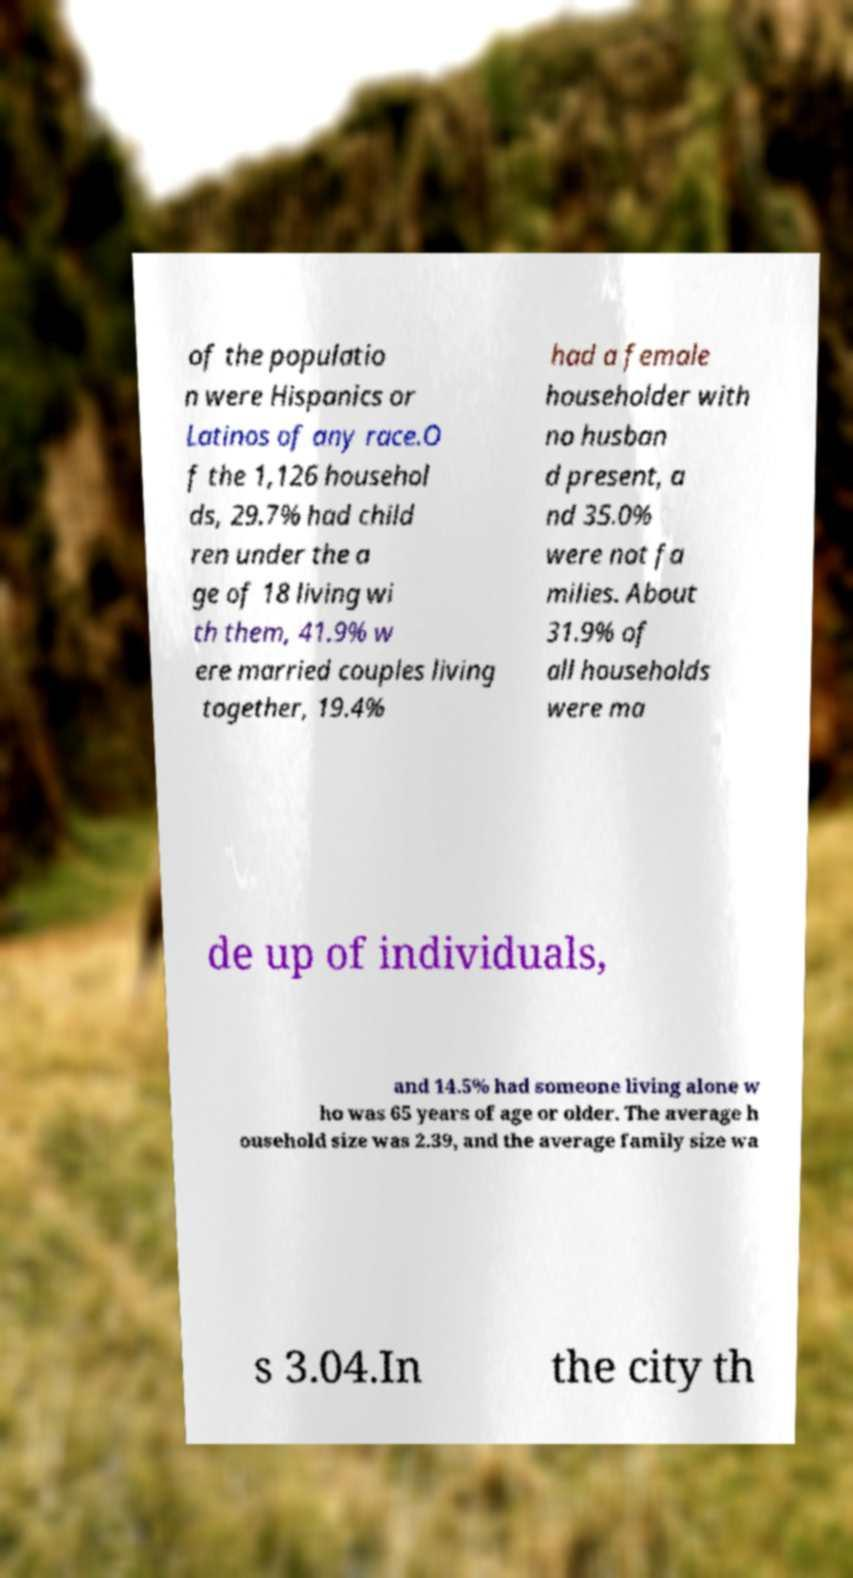Can you accurately transcribe the text from the provided image for me? of the populatio n were Hispanics or Latinos of any race.O f the 1,126 househol ds, 29.7% had child ren under the a ge of 18 living wi th them, 41.9% w ere married couples living together, 19.4% had a female householder with no husban d present, a nd 35.0% were not fa milies. About 31.9% of all households were ma de up of individuals, and 14.5% had someone living alone w ho was 65 years of age or older. The average h ousehold size was 2.39, and the average family size wa s 3.04.In the city th 